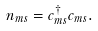Convert formula to latex. <formula><loc_0><loc_0><loc_500><loc_500>n _ { m s } = c _ { m s } ^ { \dagger } c _ { m s } .</formula> 